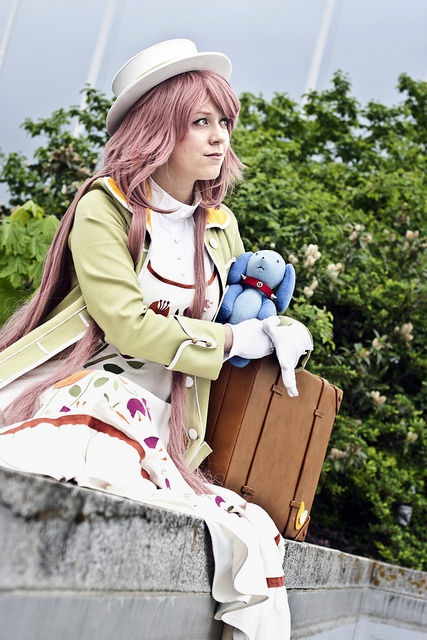Describe the objects in this image and their specific colors. I can see people in lightgray, white, beige, pink, and darkgray tones, suitcase in lightgray, gray, maroon, tan, and black tones, and teddy bear in lightgray, lavender, lightblue, and gray tones in this image. 